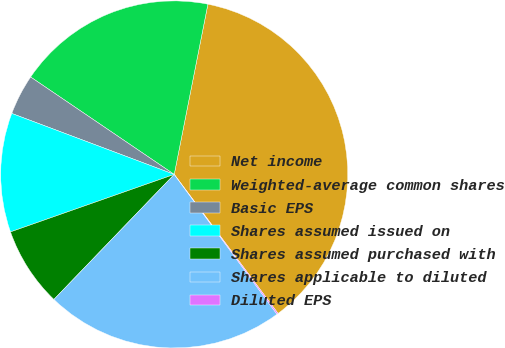<chart> <loc_0><loc_0><loc_500><loc_500><pie_chart><fcel>Net income<fcel>Weighted-average common shares<fcel>Basic EPS<fcel>Shares assumed issued on<fcel>Shares assumed purchased with<fcel>Shares applicable to diluted<fcel>Diluted EPS<nl><fcel>36.68%<fcel>18.62%<fcel>3.77%<fcel>11.09%<fcel>7.43%<fcel>22.28%<fcel>0.12%<nl></chart> 